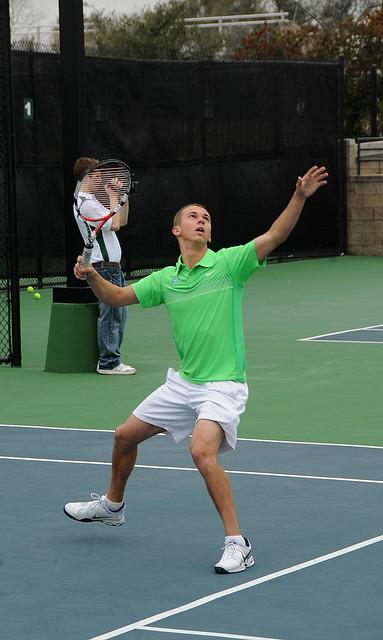What is the man in back of the player doing?
Concise answer only. Standing. Has he hit the ball?
Concise answer only. No. Are they on the court?
Answer briefly. Yes. What is the man in the white shirt holding?
Keep it brief. Camera. Why is the young man in green shirt and white shorts have his back foot off the ground?
Write a very short answer. To hit ball. 